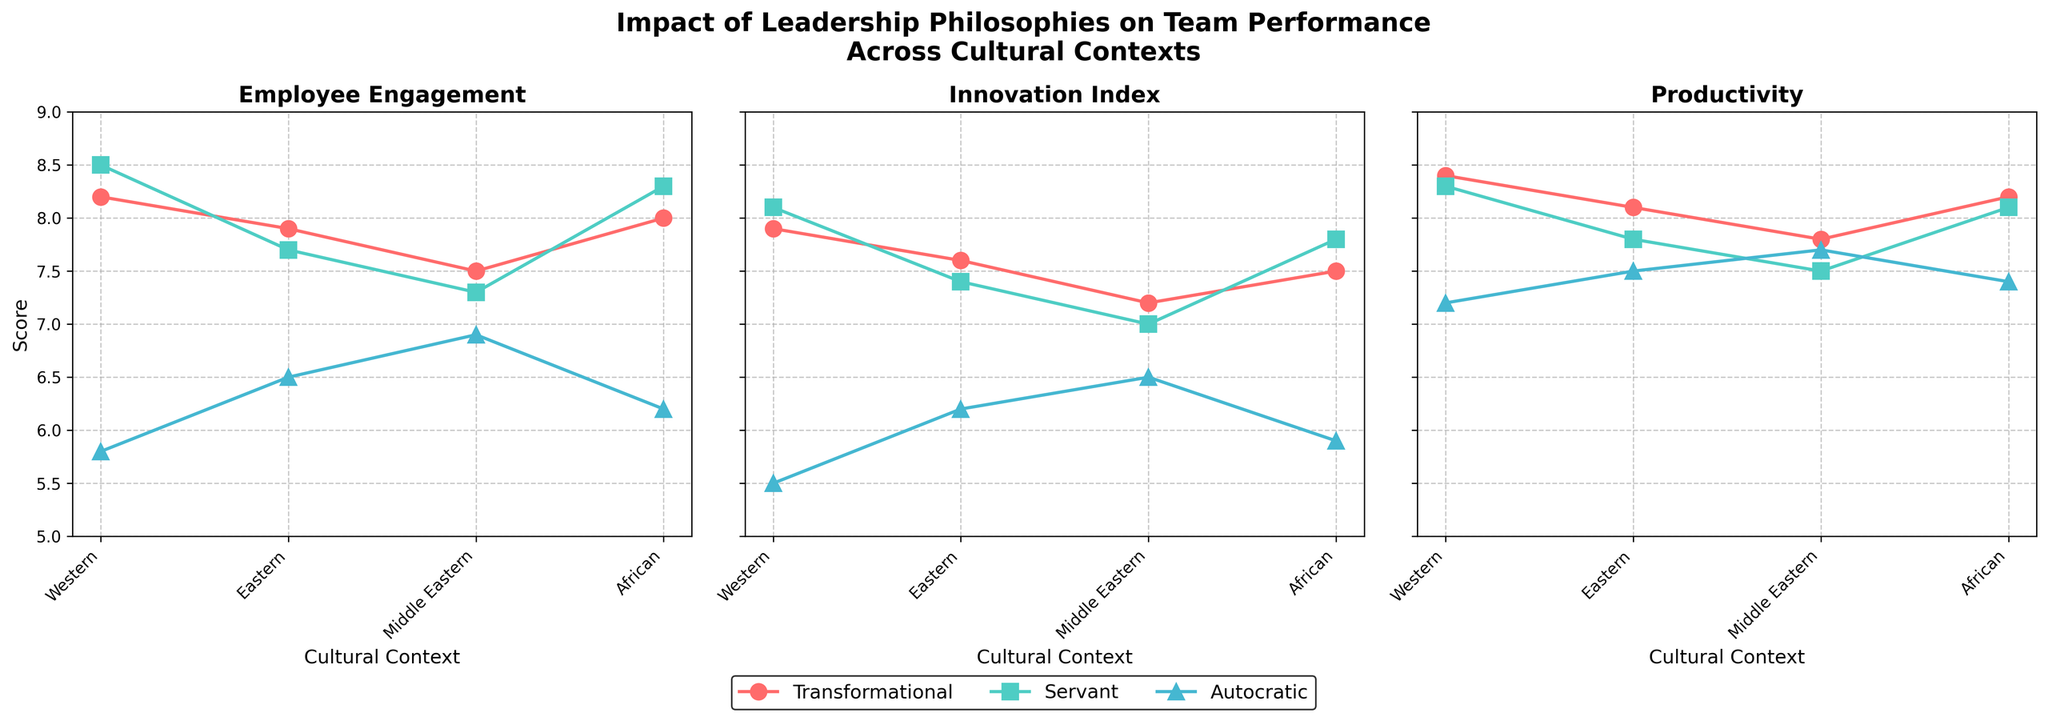What are the cultural contexts shown in the figure? The cultural contexts shown can be seen on the x-axis of the subplots. They are Western, Eastern, Middle Eastern, and African.
Answer: Western, Eastern, Middle Eastern, African Which leadership philosophy scored the highest in Employee Engagement in the African context? To find this, you look at the first subplot for Employee Engagement. The Servant leadership philosophy has the highest point in the African context.
Answer: Servant Compare the Innovation Index scores between Transformational and Autocratic leadership in the Western context. In the second subplot for Innovation Index, compare the scores for Transformational (7.9) and Autocratic (5.5) leadership in the Western context. Transformational is higher.
Answer: Transformational: 7.9, Autocratic: 5.5 What is the average Productivity score for Eastern context across all leadership philosophies? Identify the Productivity scores for Transformational (8.1), Servant (7.8), and Autocratic (7.5) in Eastern context. Sum these scores: 8.1 + 7.8 + 7.5 = 23.4. The number of philosophies is 3, so the average is 23.4 / 3 = 7.8.
Answer: 7.8 Which leadership philosophy has the lowest overall scores in all team performance metrics across Western context? Look across all three subplots for Western context and observe the scores for each philosophy. Autocratic shows the lowest scores: Employee Engagement (5.8), Innovation Index (5.5), Productivity (7.2).
Answer: Autocratic Is there any leadership philosophy that consistently performs the best in the African context across all metrics? Compare the scores for each philosophy in the African context across all subplots. Servant leadership has high scores consistently: Employee Engagement (8.3), Innovation Index (7.8), Productivity (8.1).
Answer: Yes, Servant What is the difference in Innovation Index between Servant and Autocratic leadership in the Middle Eastern context? In the second subplot for Innovation Index, find the scores for Servant (7.0) and Autocratic (6.5) in the Middle Eastern context. The difference is 7.0 - 6.5 = 0.5.
Answer: 0.5 Which cultural context shows the highest Productivity score for Transformational leadership? In the third subplot for Productivity, observe the scores for Transformational leadership across all contexts. The highest score is in Western context (8.4).
Answer: Western How does Employee Engagement under Autocratic leadership in the Eastern context compare to the same under Servant leadership in the same context? For the Eastern context in the first subplot, compare Employee Engagement scores: Autocratic (6.5) vs. Servant (7.7). Servant is higher.
Answer: Servant is higher than Autocratic Which leadership philosophy shows the least variability in scores across different cultural contexts for the Innovation Index? Observe the range of scores for each leadership philosophy in the second subplot. Transformational ranges from 7.2 to 7.9, Servant from 7.0 to 8.1, and Autocratic from 5.5 to 6.5. Transformational has the smallest range.
Answer: Transformational 